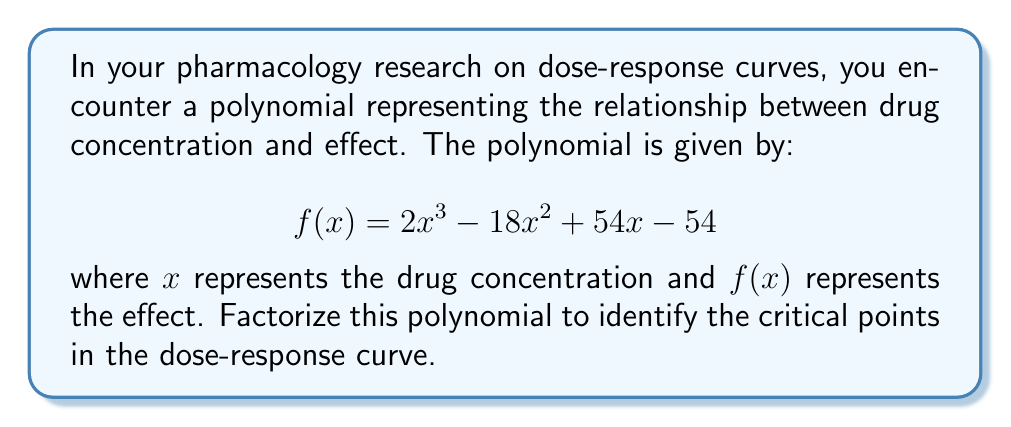Can you solve this math problem? To factorize this polynomial, we'll follow these steps:

1) First, let's check if there's a common factor:
   There's no common factor for all terms, so we proceed to the next step.

2) This is a cubic polynomial, so we'll try to factor it as:
   $$f(x) = a(x - r)(x - s)(x - t)$$
   where $r$, $s$, and $t$ are the roots of the polynomial.

3) We can try to guess one root. Let's check if $x = 3$ is a root:
   $f(3) = 2(3)^3 - 18(3)^2 + 54(3) - 54$
         $= 54 - 162 + 162 - 54 = 0$
   
   Indeed, $x = 3$ is a root.

4) Now we can factor out $(x - 3)$:
   $$f(x) = (x - 3)(2x^2 - 12x + 18)$$

5) For the quadratic factor, we can use the quadratic formula or factoring by grouping:
   $2x^2 - 12x + 18 = 2(x^2 - 6x + 9) = 2(x - 3)^2$

6) Therefore, the fully factored polynomial is:
   $$f(x) = (x - 3)(2(x - 3)^2) = 2(x - 3)^3$$

This factorization reveals that $x = 3$ is a triple root of the polynomial, indicating a critical point in the dose-response curve where the effect changes rapidly around this concentration.
Answer: $f(x) = 2(x - 3)^3$ 